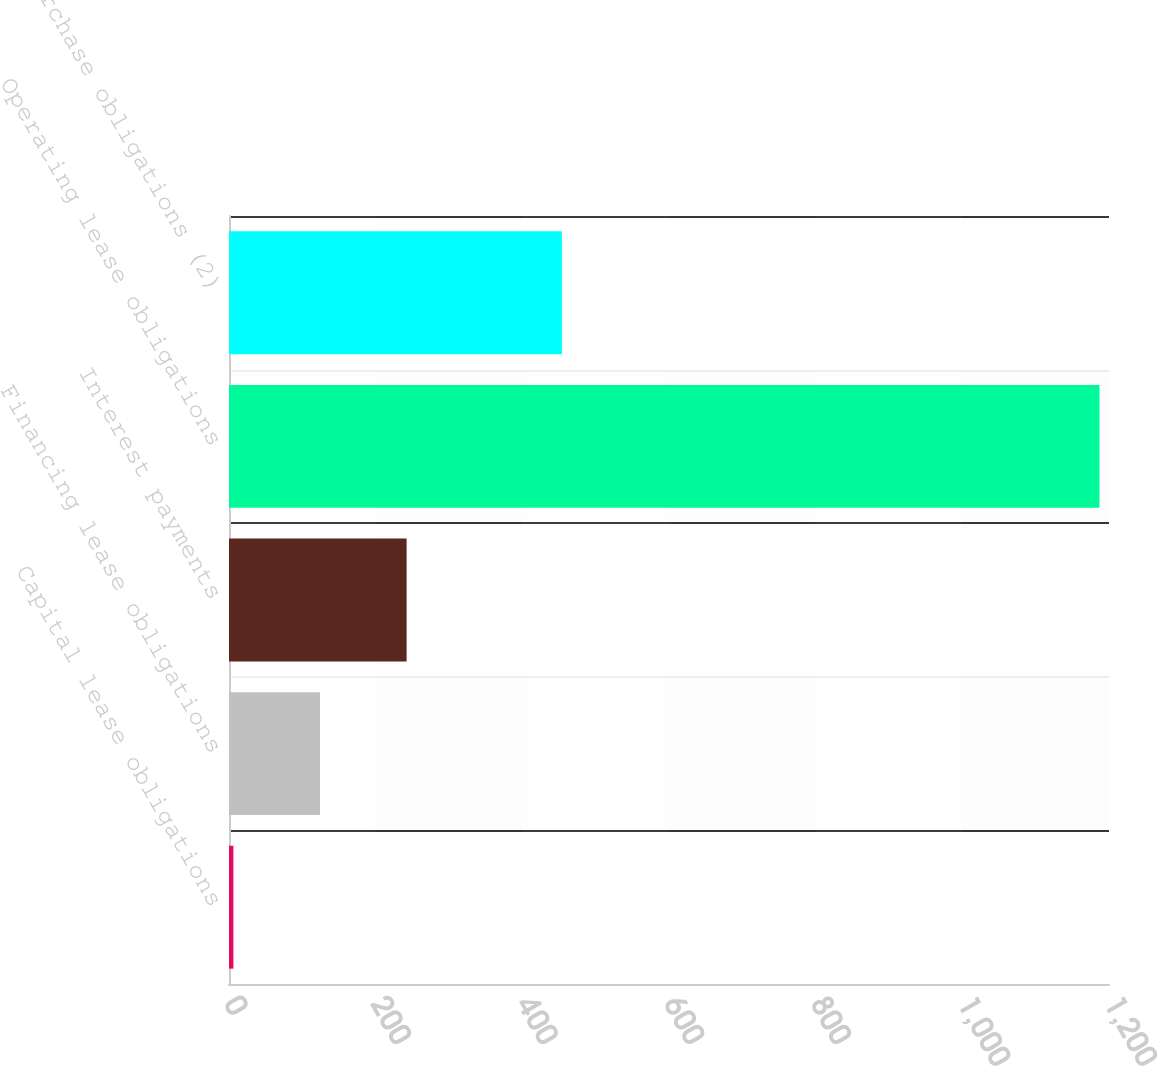Convert chart. <chart><loc_0><loc_0><loc_500><loc_500><bar_chart><fcel>Capital lease obligations<fcel>Financing lease obligations<fcel>Interest payments<fcel>Operating lease obligations<fcel>Purchase obligations (2)<nl><fcel>6<fcel>124.1<fcel>242.2<fcel>1187<fcel>454<nl></chart> 